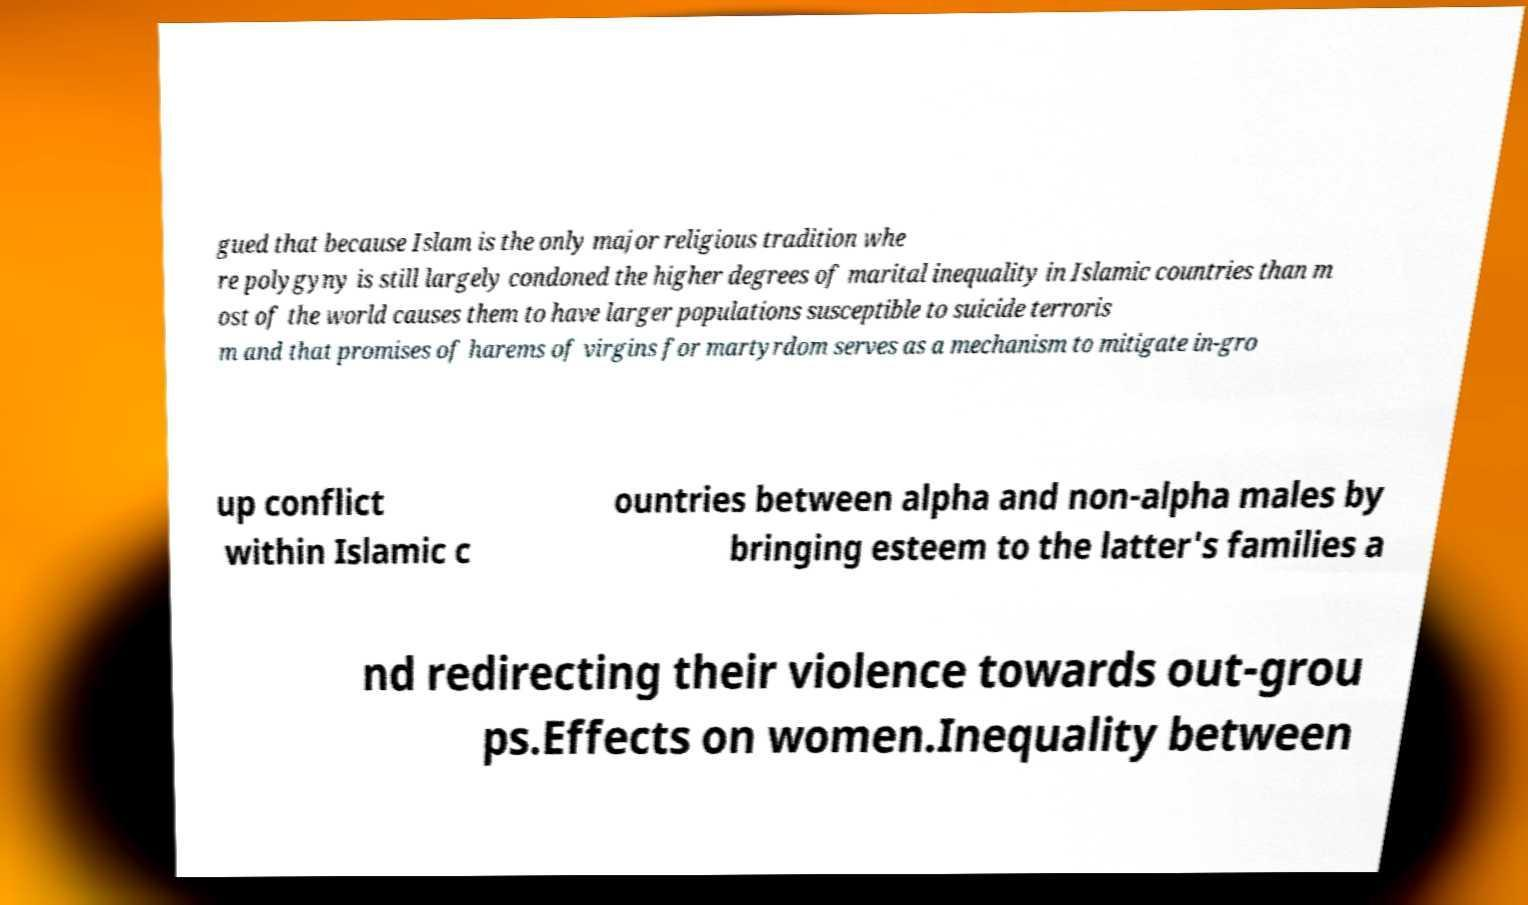Could you assist in decoding the text presented in this image and type it out clearly? gued that because Islam is the only major religious tradition whe re polygyny is still largely condoned the higher degrees of marital inequality in Islamic countries than m ost of the world causes them to have larger populations susceptible to suicide terroris m and that promises of harems of virgins for martyrdom serves as a mechanism to mitigate in-gro up conflict within Islamic c ountries between alpha and non-alpha males by bringing esteem to the latter's families a nd redirecting their violence towards out-grou ps.Effects on women.Inequality between 